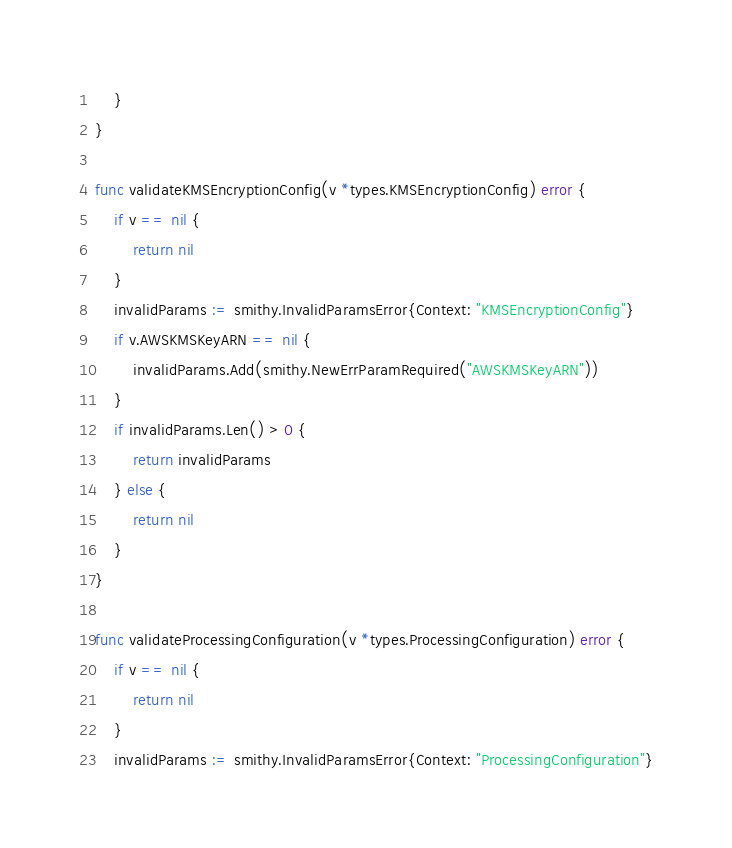Convert code to text. <code><loc_0><loc_0><loc_500><loc_500><_Go_>	}
}

func validateKMSEncryptionConfig(v *types.KMSEncryptionConfig) error {
	if v == nil {
		return nil
	}
	invalidParams := smithy.InvalidParamsError{Context: "KMSEncryptionConfig"}
	if v.AWSKMSKeyARN == nil {
		invalidParams.Add(smithy.NewErrParamRequired("AWSKMSKeyARN"))
	}
	if invalidParams.Len() > 0 {
		return invalidParams
	} else {
		return nil
	}
}

func validateProcessingConfiguration(v *types.ProcessingConfiguration) error {
	if v == nil {
		return nil
	}
	invalidParams := smithy.InvalidParamsError{Context: "ProcessingConfiguration"}</code> 